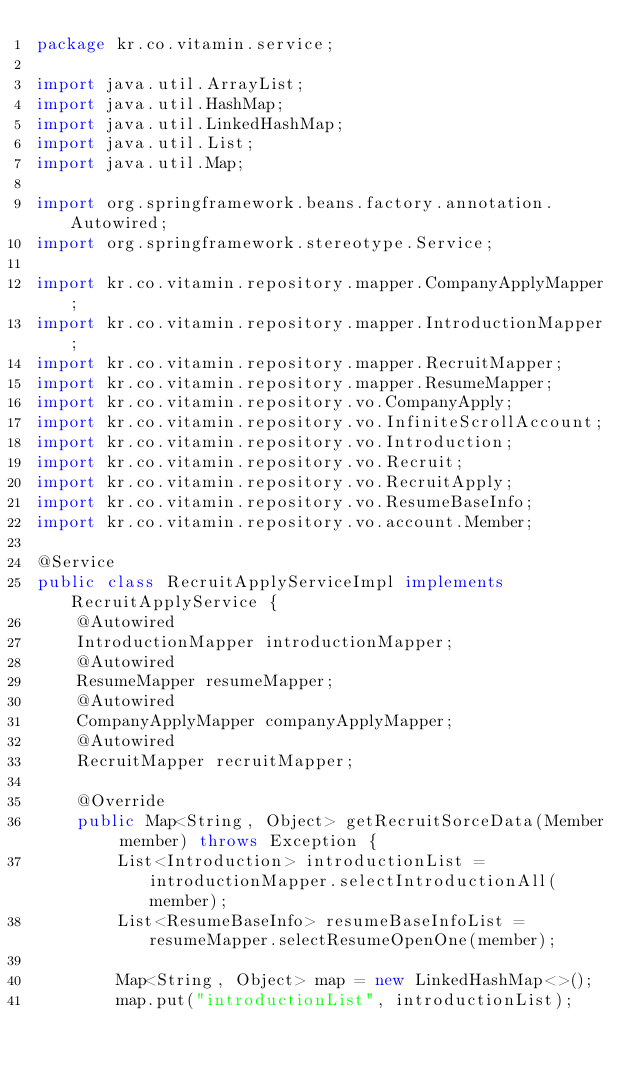<code> <loc_0><loc_0><loc_500><loc_500><_Java_>package kr.co.vitamin.service;

import java.util.ArrayList;
import java.util.HashMap;
import java.util.LinkedHashMap;
import java.util.List;
import java.util.Map;

import org.springframework.beans.factory.annotation.Autowired;
import org.springframework.stereotype.Service;

import kr.co.vitamin.repository.mapper.CompanyApplyMapper;
import kr.co.vitamin.repository.mapper.IntroductionMapper;
import kr.co.vitamin.repository.mapper.RecruitMapper;
import kr.co.vitamin.repository.mapper.ResumeMapper;
import kr.co.vitamin.repository.vo.CompanyApply;
import kr.co.vitamin.repository.vo.InfiniteScrollAccount;
import kr.co.vitamin.repository.vo.Introduction;
import kr.co.vitamin.repository.vo.Recruit;
import kr.co.vitamin.repository.vo.RecruitApply;
import kr.co.vitamin.repository.vo.ResumeBaseInfo;
import kr.co.vitamin.repository.vo.account.Member;

@Service
public class RecruitApplyServiceImpl implements RecruitApplyService {
	@Autowired
	IntroductionMapper introductionMapper;
	@Autowired
	ResumeMapper resumeMapper;
	@Autowired
	CompanyApplyMapper companyApplyMapper;
	@Autowired
	RecruitMapper recruitMapper;
	
	@Override
	public Map<String, Object> getRecruitSorceData(Member member) throws Exception {
		List<Introduction> introductionList = introductionMapper.selectIntroductionAll(member);
		List<ResumeBaseInfo> resumeBaseInfoList = resumeMapper.selectResumeOpenOne(member);
		
		Map<String, Object> map = new LinkedHashMap<>();
		map.put("introductionList", introductionList);</code> 